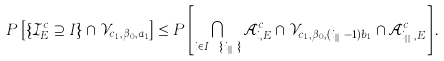Convert formula to latex. <formula><loc_0><loc_0><loc_500><loc_500>P \left [ \left \{ { \mathcal { I } } _ { E } ^ { c } \supseteq I \right \} \cap { \mathcal { V } } _ { c _ { 1 } , \beta _ { 0 } , a _ { 1 } } \right ] \leq P \left [ \bigcap _ { i \in I \ \{ i _ { | I | } \} } { \mathcal { A } } _ { i , E } ^ { c } \cap { \mathcal { V } } _ { c _ { 1 } , \beta _ { 0 } , ( i _ { | I | } - 1 ) b _ { 1 } } \cap { \mathcal { A } } _ { i _ { | I | } , E } ^ { c } \right ] .</formula> 